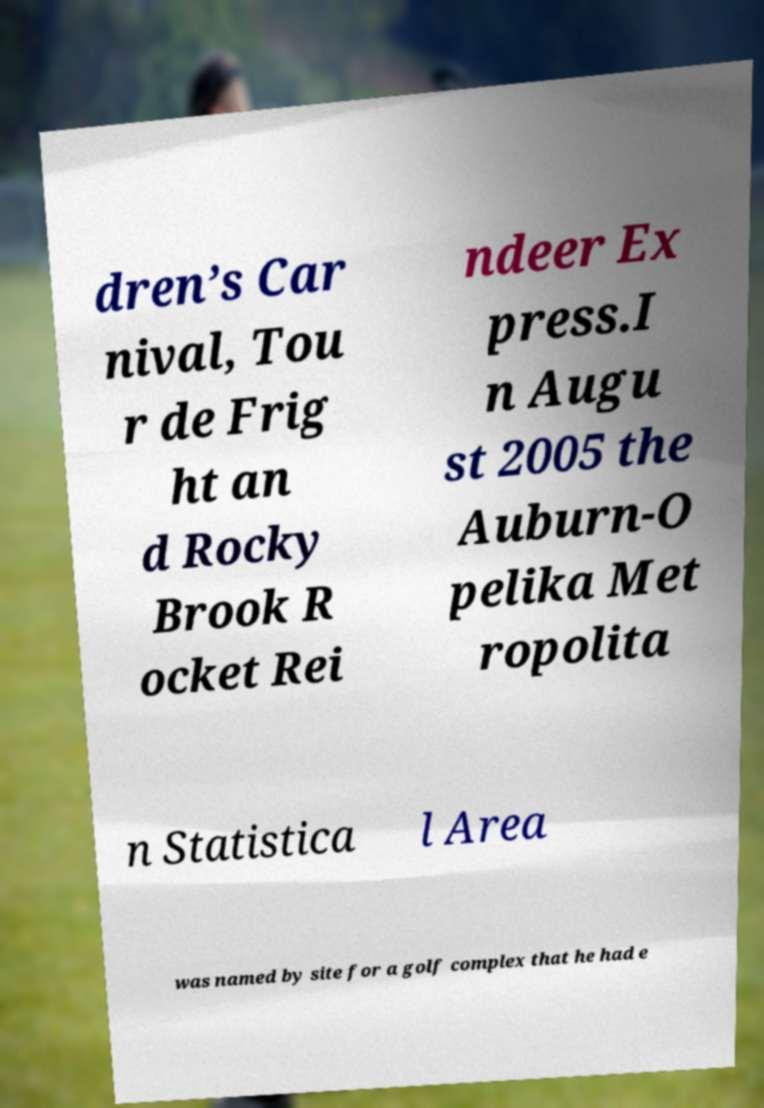Could you extract and type out the text from this image? dren’s Car nival, Tou r de Frig ht an d Rocky Brook R ocket Rei ndeer Ex press.I n Augu st 2005 the Auburn-O pelika Met ropolita n Statistica l Area was named by site for a golf complex that he had e 